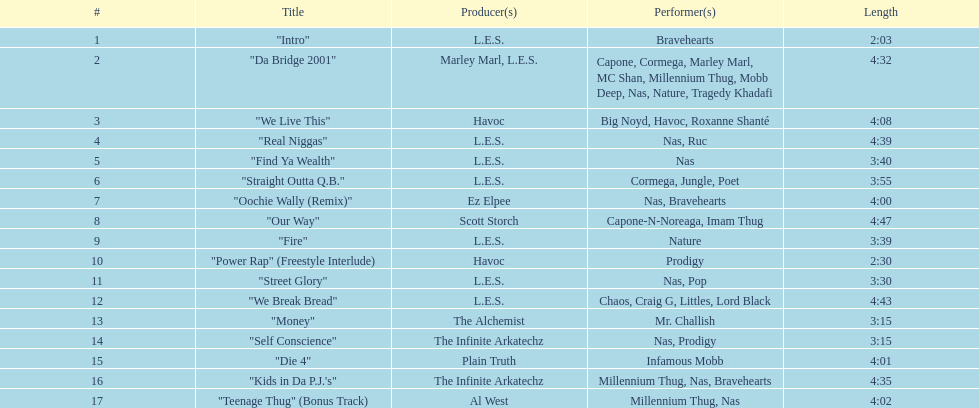How many songs are at least 4 minutes long? 9. 